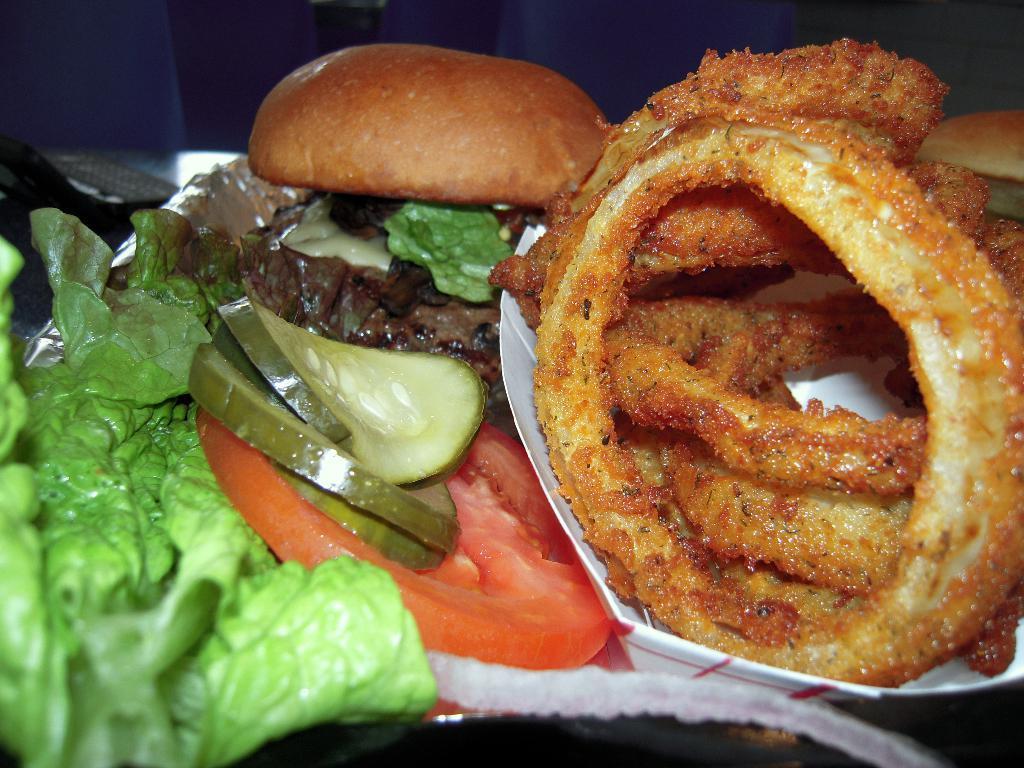In one or two sentences, can you explain what this image depicts? In this image I can see the food which is in brown, green, red and cream color on the paper and the paper is in white color. 